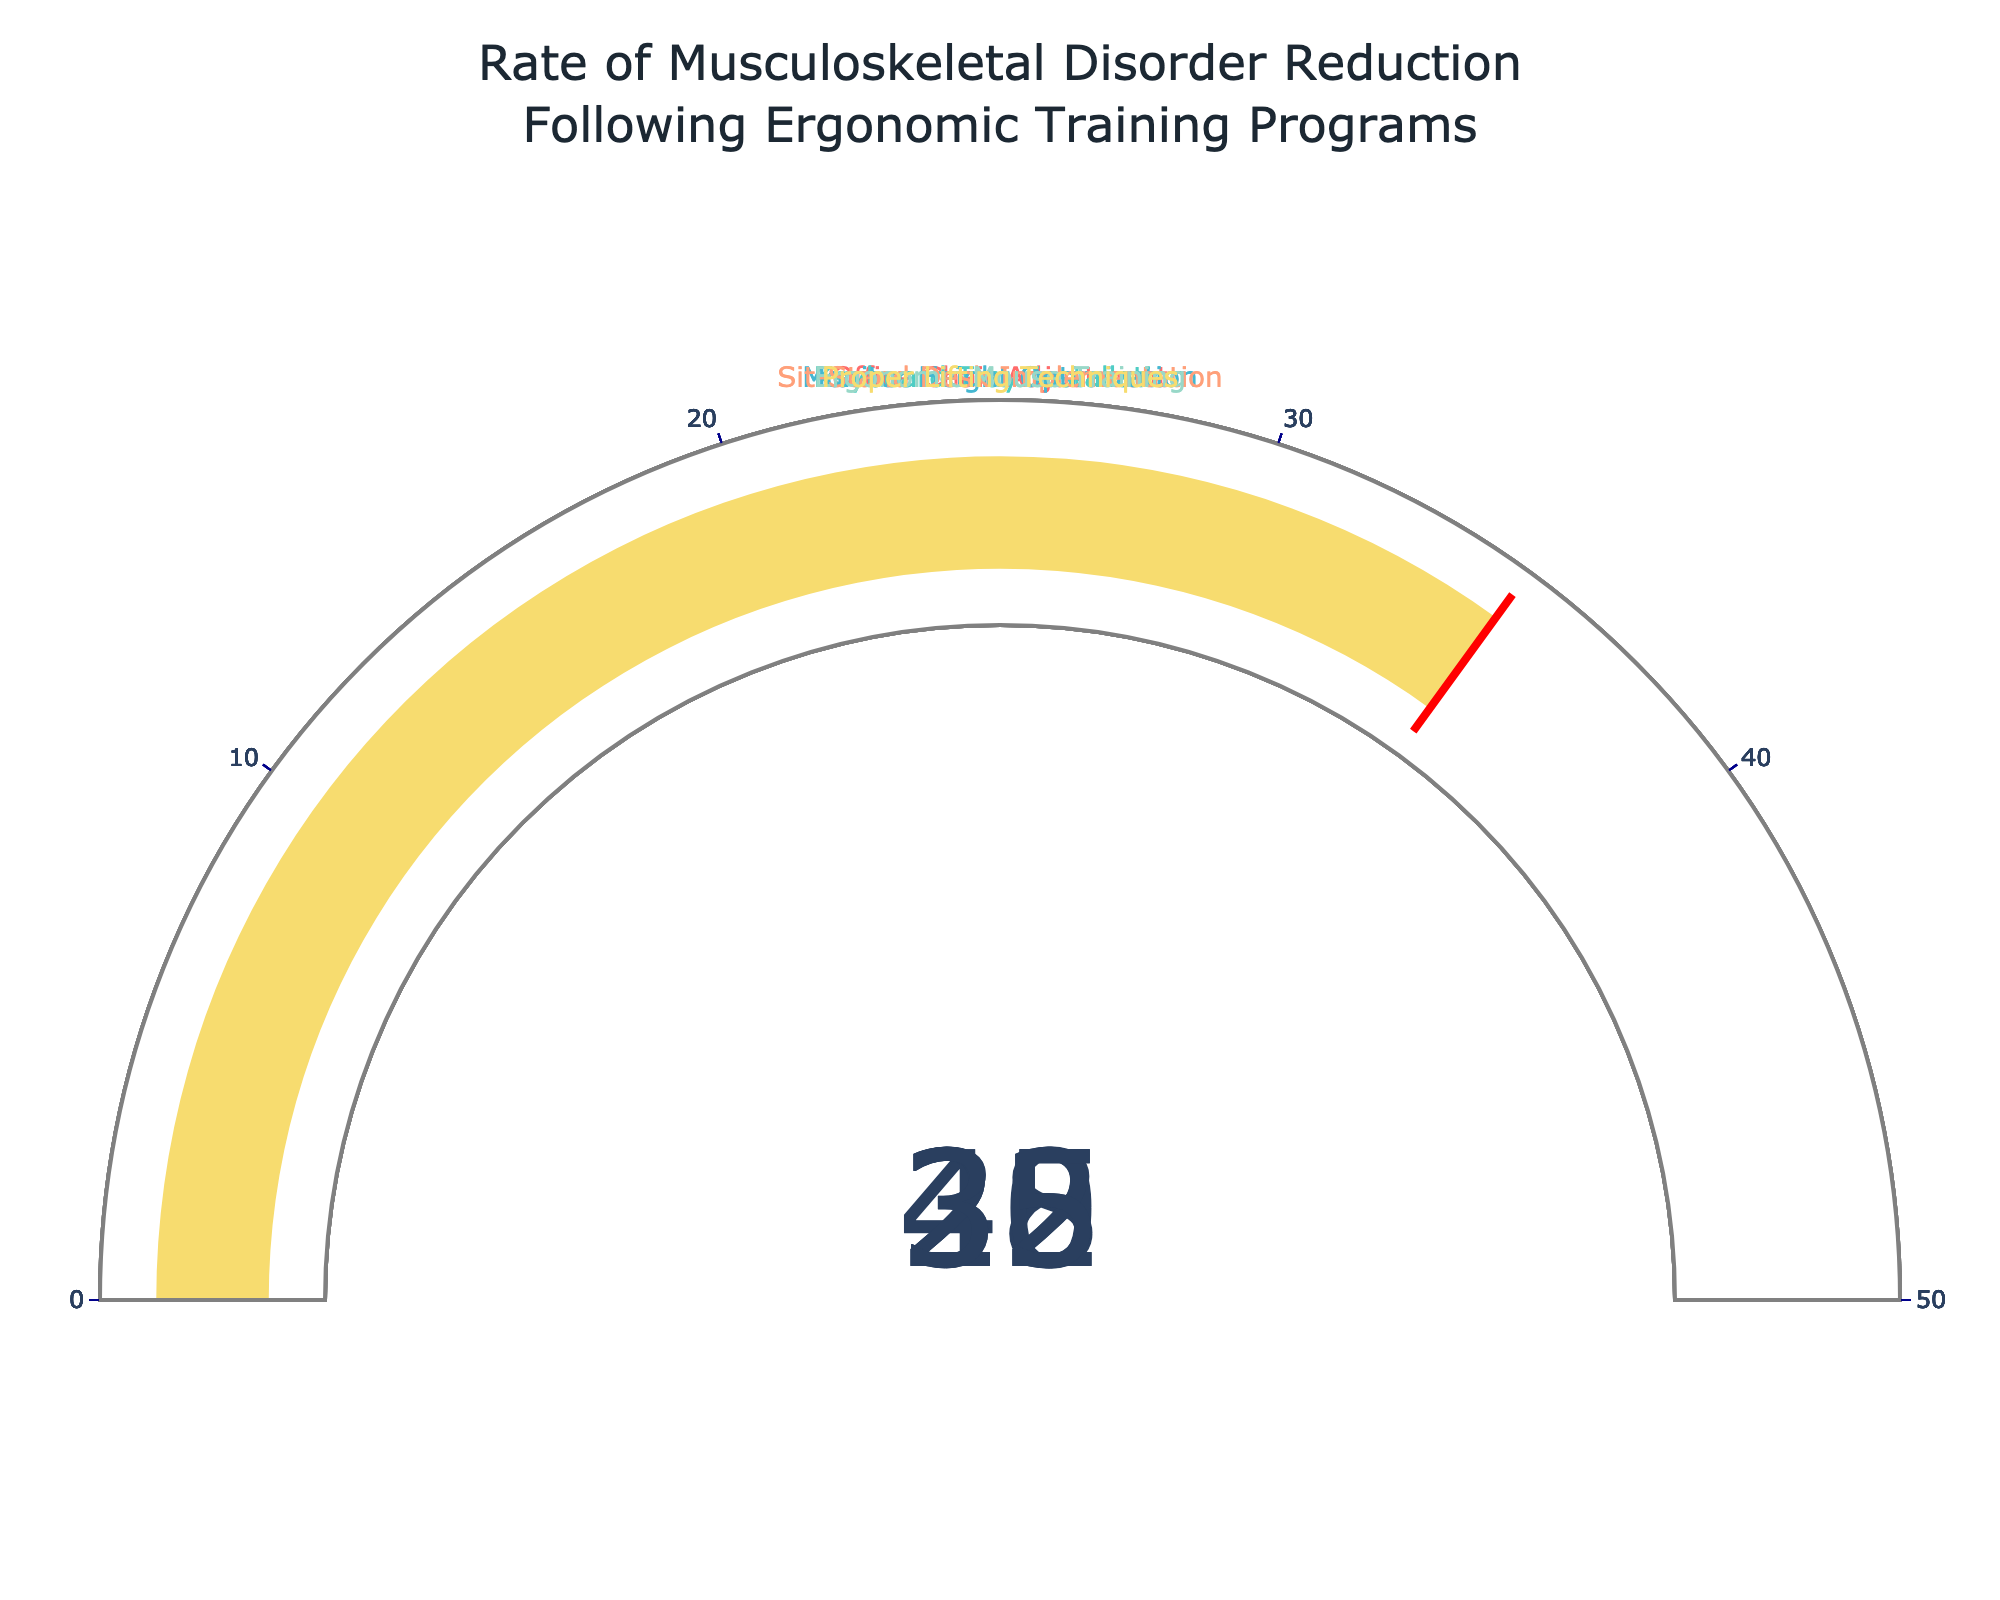What is the reduction rate for Sit-Stand Desk Implementation? The gauge for Sit-Stand Desk Implementation shows a reduction rate near its center. The number displayed without overlapping text is 40, which represents the reduction rate.
Answer: 40 Which ergonomic intervention has the highest reduction rate? To find the highest reduction rate, we examine each gauge to identify the maximum value. Sit-Stand Desk Implementation shows the highest value among all interventions.
Answer: Sit-Stand Desk Implementation Which ergonomic intervention has the lowest reduction rate? By examining the gauges, Ergonomic Mouse Training shows the lowest value among all interventions.
Answer: Ergonomic Mouse Training What is the difference in reduction rates between Office Chair Adjustment and Proper Lifting Techniques? Office Chair Adjustment's gauge shows a reduction rate of 32, and Proper Lifting Techniques shows 35. The difference is calculated as 35 - 32.
Answer: 3 What is the average reduction rate for all interventions shown in the figure? The reduction rates are 32 (Office Chair Adjustment), 28 (Keyboard Tray Installation), 25 (Monitor Height Optimization), 40 (Sit-Stand Desk Implementation), 22 (Ergonomic Mouse Training), and 35 (Proper Lifting Techniques). Sum them up (32 + 28 + 25 + 40 + 22 + 35 = 182), then divide by 6 (the number of interventions). 182 / 6 = 30.33.
Answer: 30.33 Is the reduction rate for Monitor Height Optimization higher than the one for Ergonomic Mouse Training? By comparing the gauges, the reduction rate for Monitor Height Optimization is 25, which is higher than Ergonomic Mouse Training's 22.
Answer: Yes What is the sum of the reduction rates for Keyboard Tray Installation and Monitor Height Optimization? The reduction rate for Keyboard Tray Installation is 28, and for Monitor Height Optimization, it is 25. Summing these values, 28 + 25 = 53.
Answer: 53 Which ergonomic interventions have a reduction rate greater than 30? By examining the reduction rates for each intervention, Office Chair Adjustment (32), Sit-Stand Desk Implementation (40), and Proper Lifting Techniques (35) all have reduction rates greater than 30.
Answer: Office Chair Adjustment, Sit-Stand Desk Implementation, Proper Lifting Techniques What color represents the gauge for Ergonomic Mouse Training? Each gauge is assigned a different color. The gauge for Ergonomic Mouse Training is filled with a color distinct to its data point. The exact color is '#F7DC6F' as defined in the code but is visually yellowish.
Answer: Yellowish How many ergonomic interventions have a reduction rate less than or equal to 32? By examining each gauge, Keyboard Tray Installation (28), Monitor Height Optimization (25), and Ergonomic Mouse Training (22) have reduction rates less than or equal to 32, totaling 3 interventions.
Answer: 3 